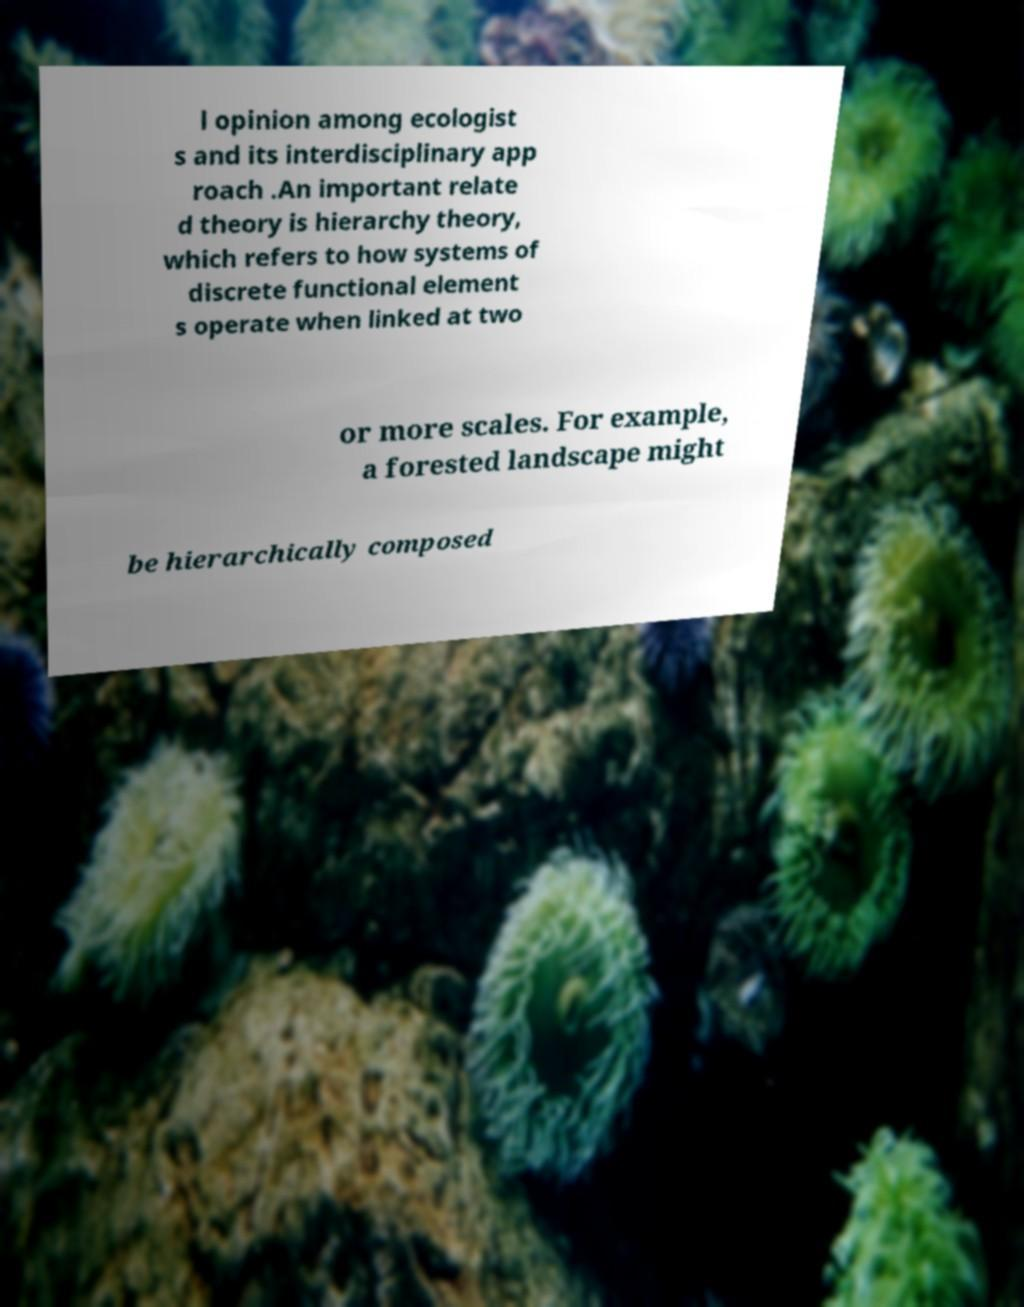Could you extract and type out the text from this image? l opinion among ecologist s and its interdisciplinary app roach .An important relate d theory is hierarchy theory, which refers to how systems of discrete functional element s operate when linked at two or more scales. For example, a forested landscape might be hierarchically composed 